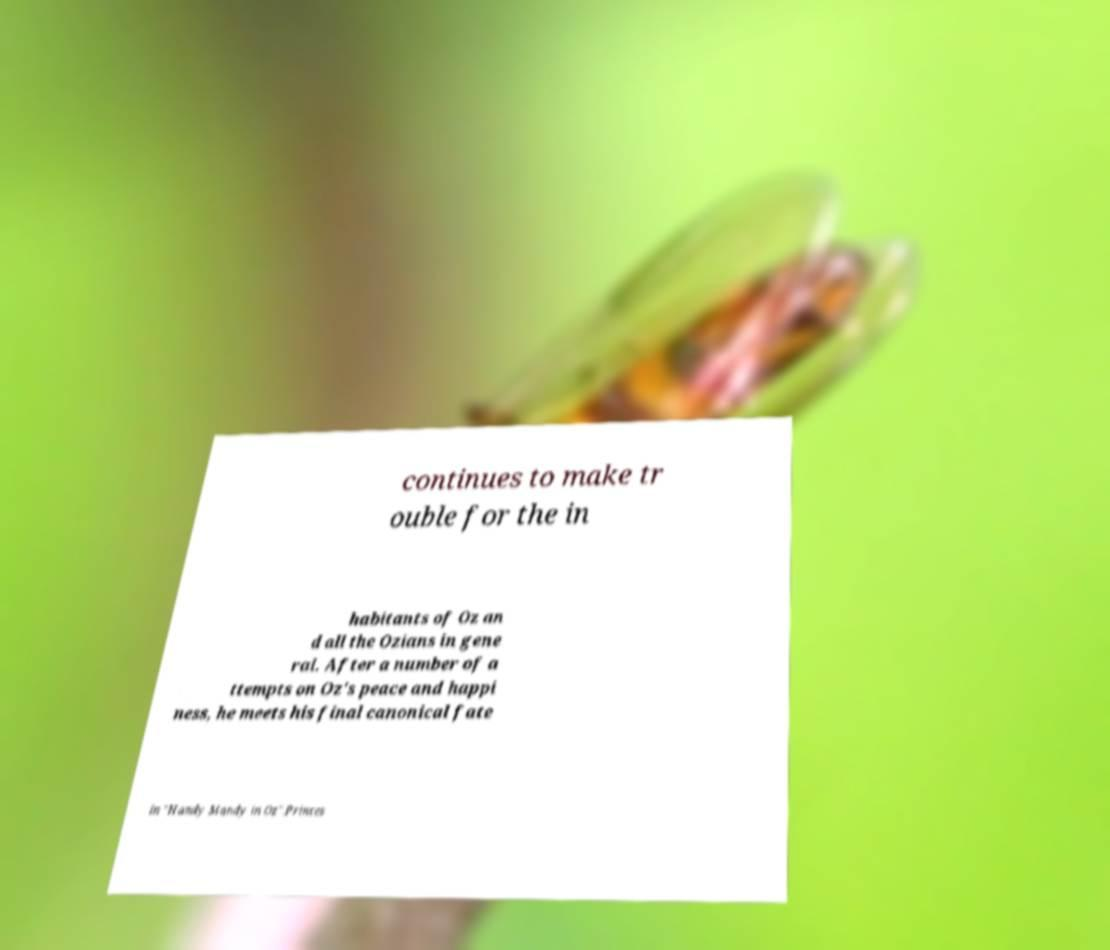Can you accurately transcribe the text from the provided image for me? continues to make tr ouble for the in habitants of Oz an d all the Ozians in gene ral. After a number of a ttempts on Oz's peace and happi ness, he meets his final canonical fate in "Handy Mandy in Oz".Princes 